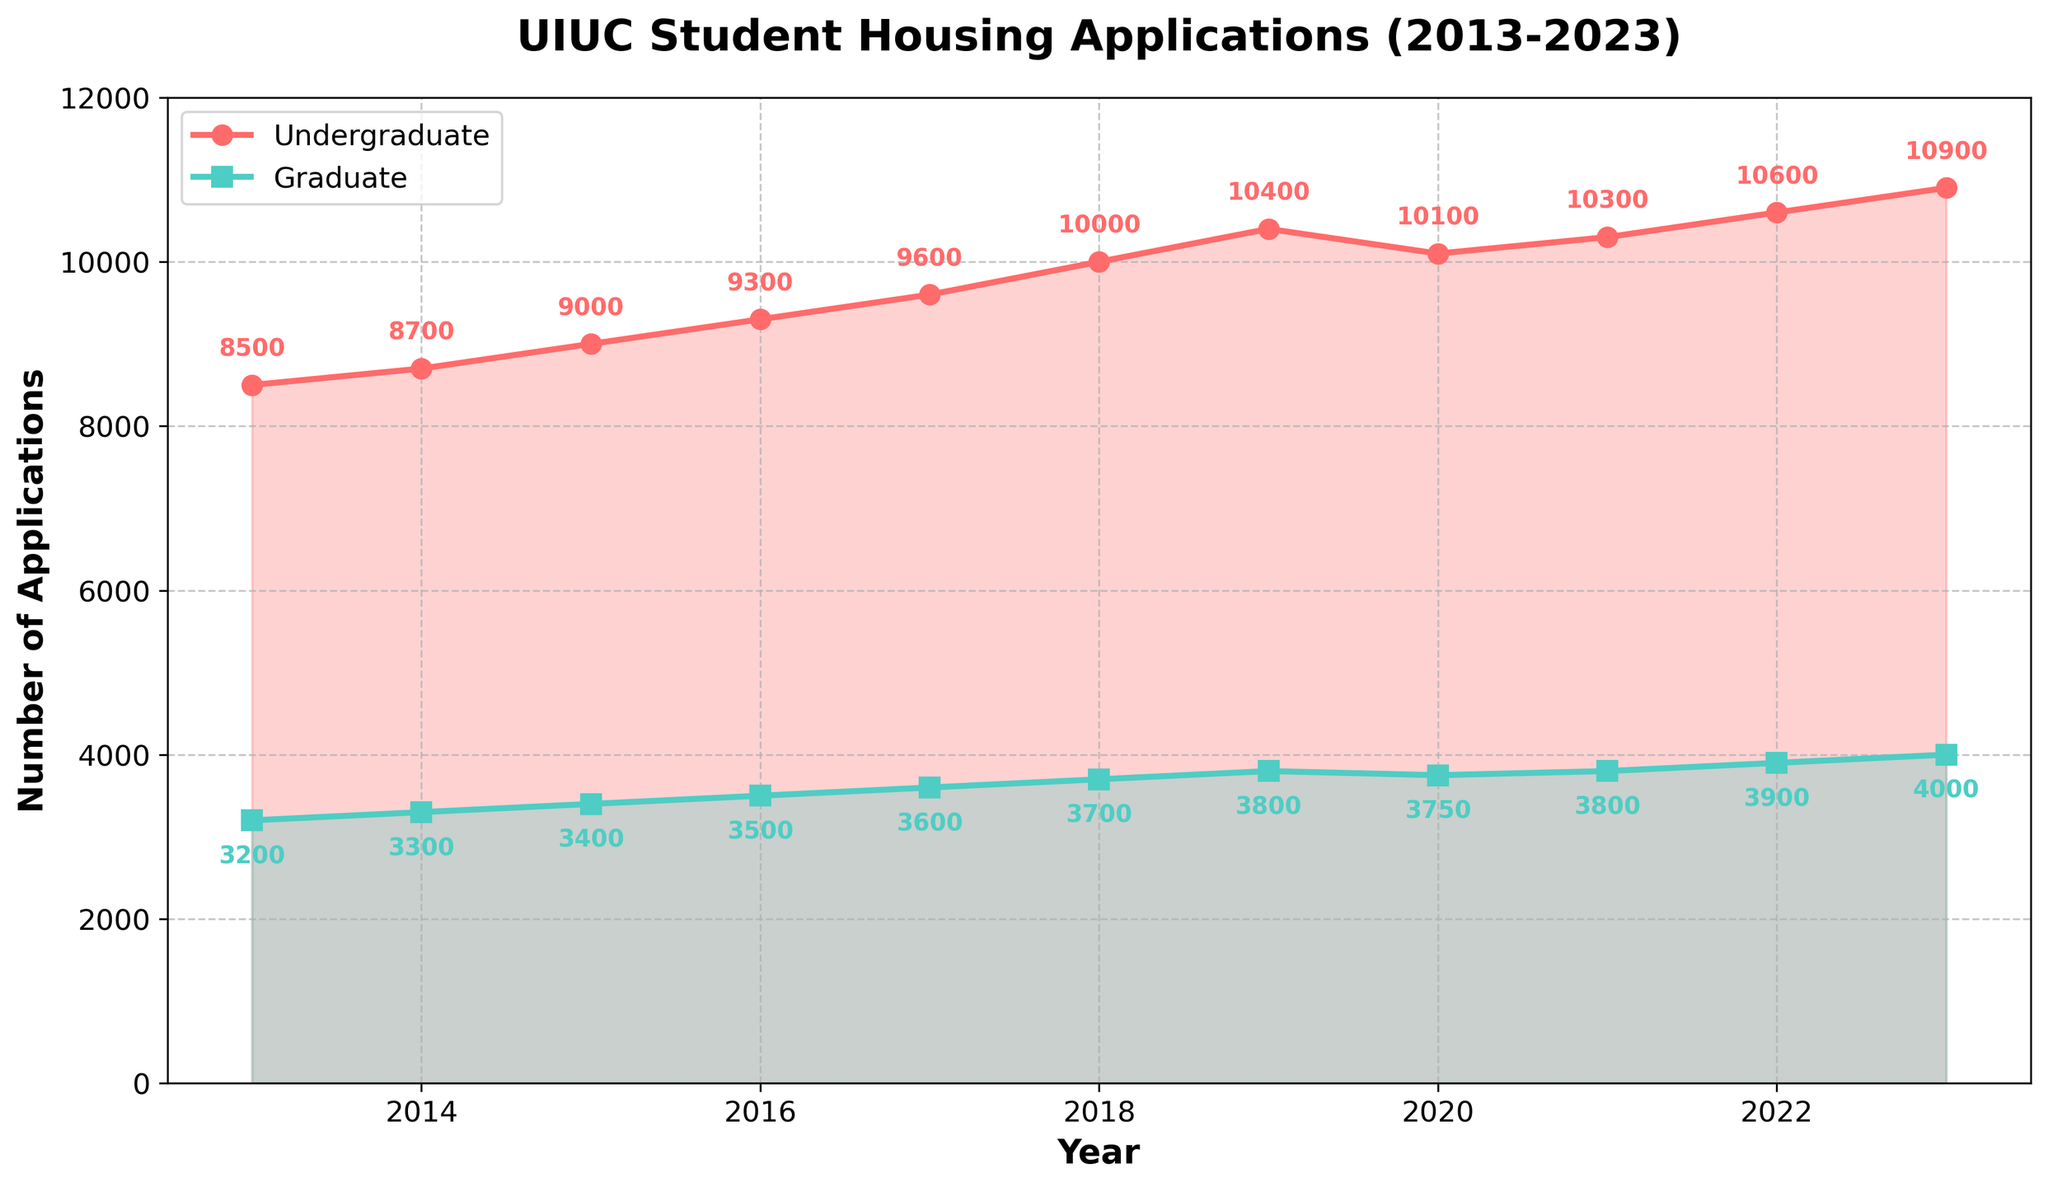What was the overall trend in undergraduate applications from 2013 to 2023? The undergraduate applications generally increased every year from 2013 to 2023, starting from 8500 applications in 2013 and ending with 10900 applications in 2023.
Answer: Increasing What year saw the largest increase in graduate applications compared to the previous year? Comparing the differences in graduate applications between consecutive years: the highest jump is from 2013 to 2014 (100 applications), 2014 to 2015 (100 applications), 2015 to 2016 (100 applications), 2016 to 2017 (100 applications), 2017 to 2018 (100 applications), 2018 to 2019 (100 applications), 2019 to 2020 (-50 applications), 2020 to 2021 (50 applications), 2021 to 2022 (100 applications), and 2022 to 2023 (100 applications). Multiple periods have equal changes, any one of which we can choose.
Answer: 2013 to 2014 or 2015 to 2016 or 2016 to 2017 or 2022 to 2023 In which year did undergraduate applications exceed 10,000 for the first time? By looking at the graph, it's clear that the undergraduate applications crossed the 10,000 threshold between 2017 and 2018, with the exact first occurrence being in 2018 with 10,000 applications.
Answer: 2018 How many more undergraduate applications were there in 2023 compared to 2013? In 2013, there were 8500 undergraduate applications. In 2023, there were 10900 undergraduate applications. The difference between 2023 and 2013 is 10900 - 8500 = 2400.
Answer: 2400 What is the average number of graduate applications from 2013 to 2023? Sum the number of graduate applications from each year and divide by the number of years: (3200 + 3300 + 3400 + 3500 + 3600 + 3700 + 3800 + 3750 + 3800 + 3900 + 4000) / 11 = 39950 / 11 ≈ 3632.
Answer: 3632 Between which two consecutive years was the smallest increase in undergraduate applications? Analyzing the differences between each consecutive year for undergraduate applications: 2013 to 2014 (200), 2014 to 2015 (300), 2015 to 2016 (300), 2016 to 2017 (300), 2017 to 2018 (400), 2018 to 2019 (400), 2019 to 2020 (-300), 2020 to 2021 (200), 2021 to 2022 (300), 2022 to 2023 (300). The smallest increase is 0, occurring between 2019 and 2020.
Answer: 2019 and 2020 Does the graph show any periods of decline in either graduate or undergraduate applications? The graph shows a decline in undergraduate applications between 2019 and 2020 and a minor decline in graduate applications also between 2019 and 2020, otherwise, numbers generally increase.
Answer: Yes In which year were the graduate applications exactly half the number of undergraduate applications? To find when graduate applications were exactly half the undergraduate applications, see when graduate applications are close to half of undergraduate. In 2020, graduate applications were 3750 and undergraduate applications were 10100, this is not within range. Thus there is no exact year where applications are exactly half but close enough.
Answer: None 